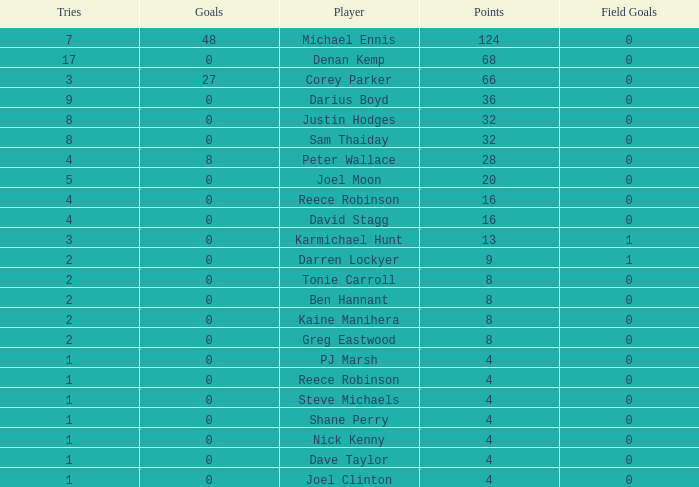What is the total number of field goals of Denan Kemp, who has more than 4 tries, more than 32 points, and 0 goals? 1.0. 